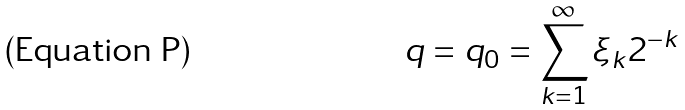<formula> <loc_0><loc_0><loc_500><loc_500>q = q _ { 0 } = \sum _ { k = 1 } ^ { \infty } \xi _ { k } 2 ^ { - k }</formula> 